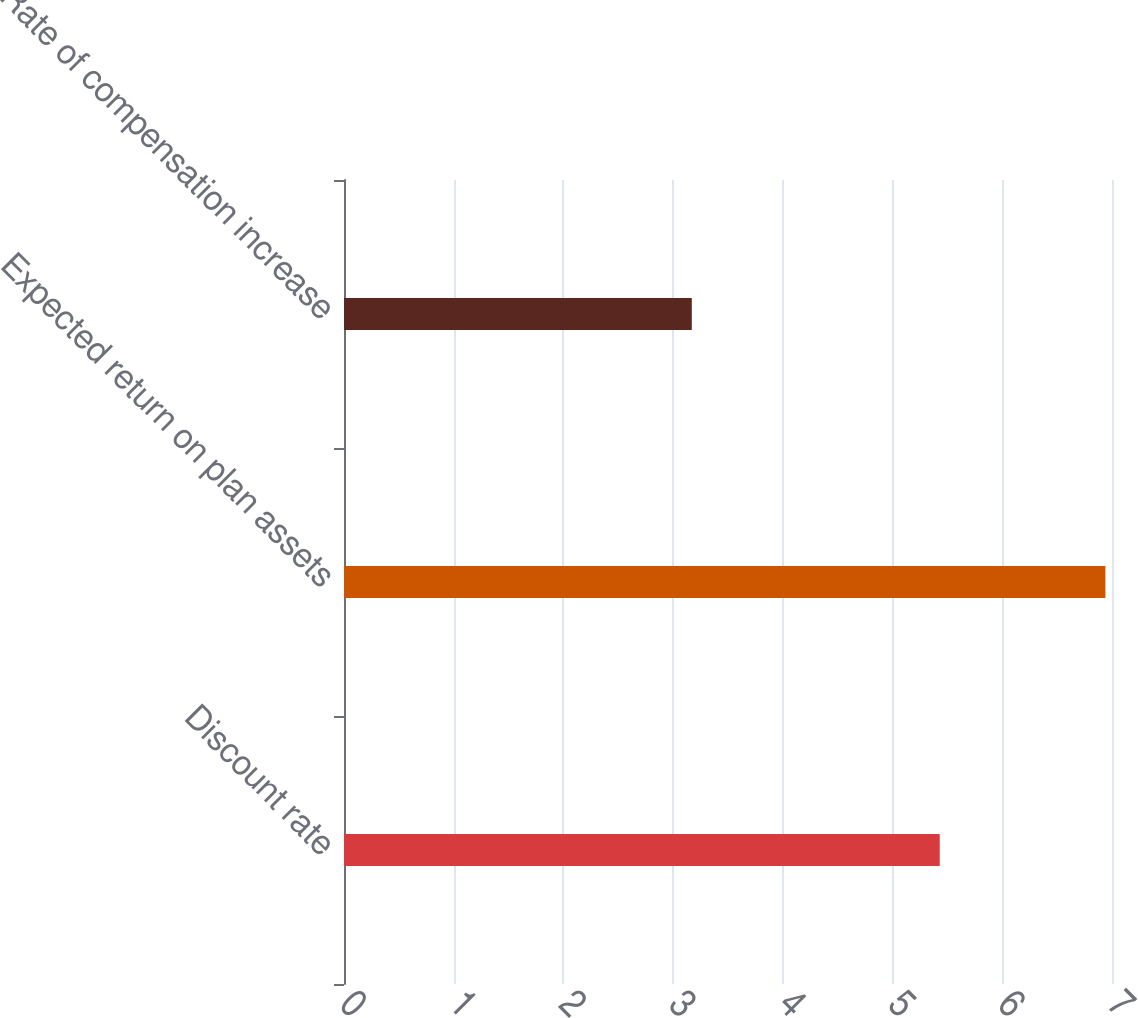<chart> <loc_0><loc_0><loc_500><loc_500><bar_chart><fcel>Discount rate<fcel>Expected return on plan assets<fcel>Rate of compensation increase<nl><fcel>5.43<fcel>6.94<fcel>3.17<nl></chart> 